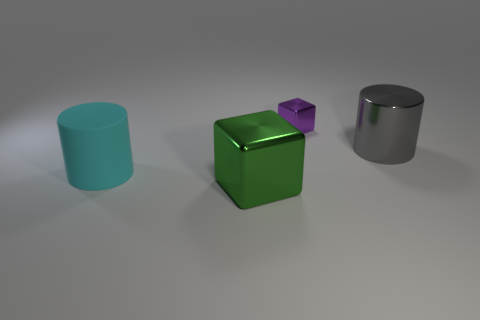Add 3 tiny rubber spheres. How many objects exist? 7 Subtract 1 gray cylinders. How many objects are left? 3 Subtract all small brown shiny balls. Subtract all big metal objects. How many objects are left? 2 Add 4 small shiny cubes. How many small shiny cubes are left? 5 Add 2 small gray shiny cylinders. How many small gray shiny cylinders exist? 2 